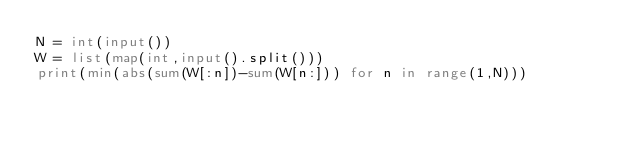Convert code to text. <code><loc_0><loc_0><loc_500><loc_500><_Python_>N = int(input())
W = list(map(int,input().split()))
print(min(abs(sum(W[:n])-sum(W[n:])) for n in range(1,N)))</code> 